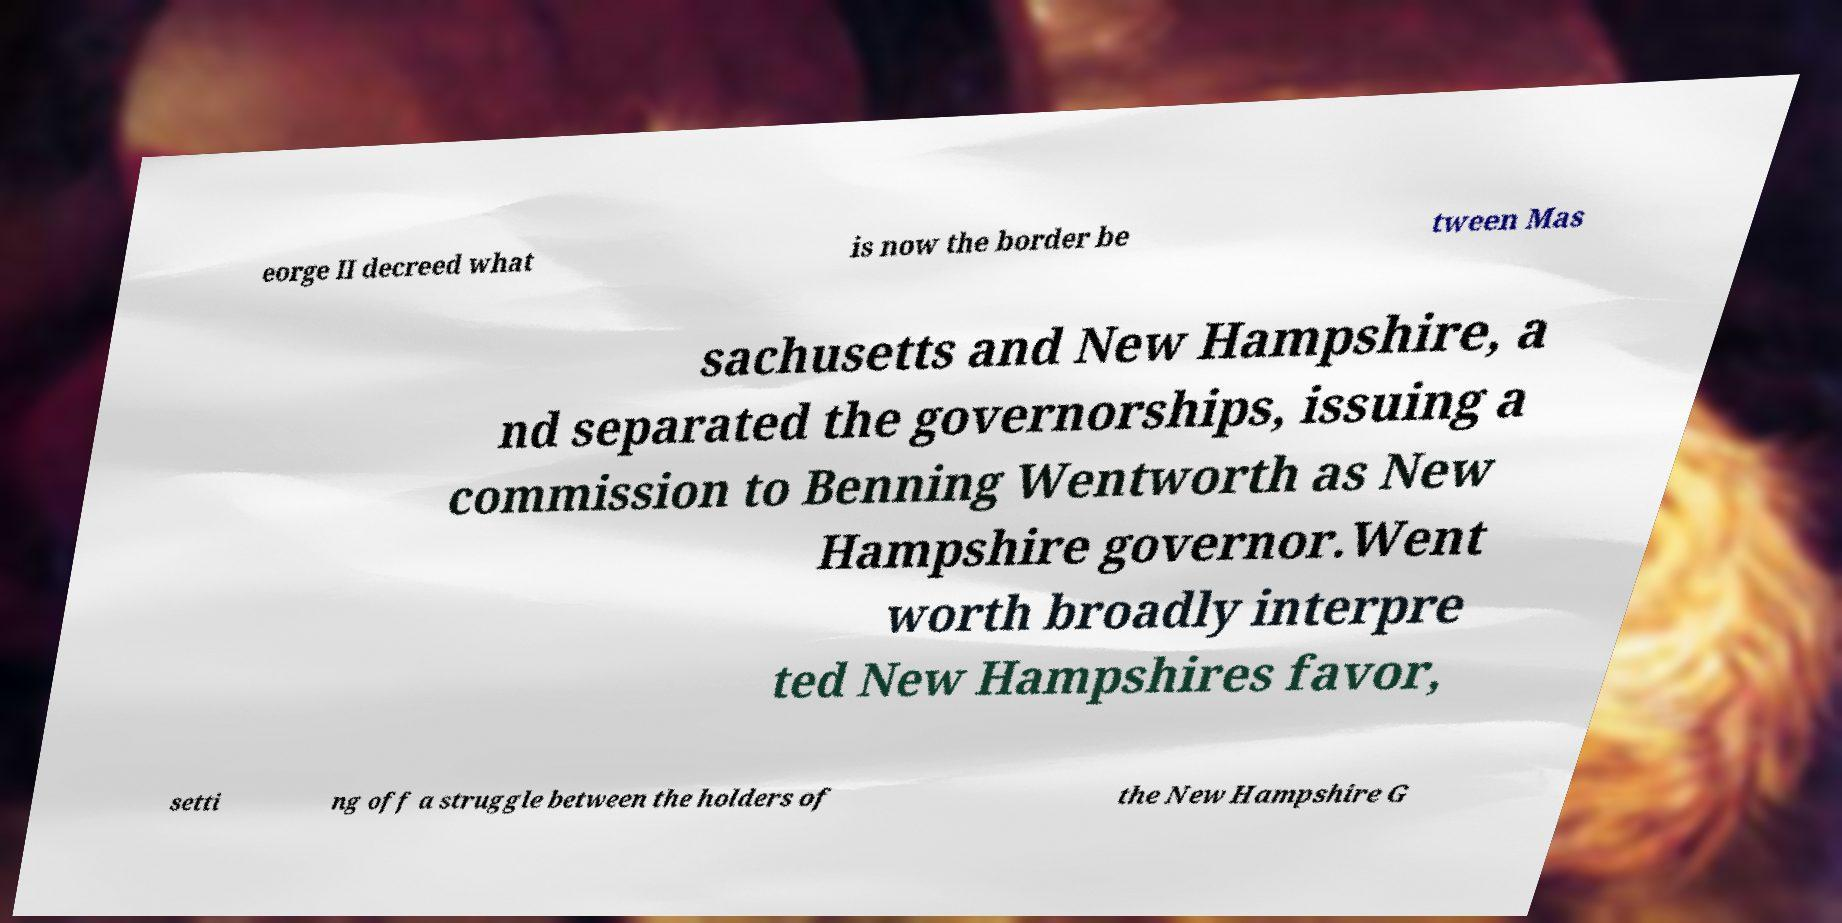There's text embedded in this image that I need extracted. Can you transcribe it verbatim? eorge II decreed what is now the border be tween Mas sachusetts and New Hampshire, a nd separated the governorships, issuing a commission to Benning Wentworth as New Hampshire governor.Went worth broadly interpre ted New Hampshires favor, setti ng off a struggle between the holders of the New Hampshire G 